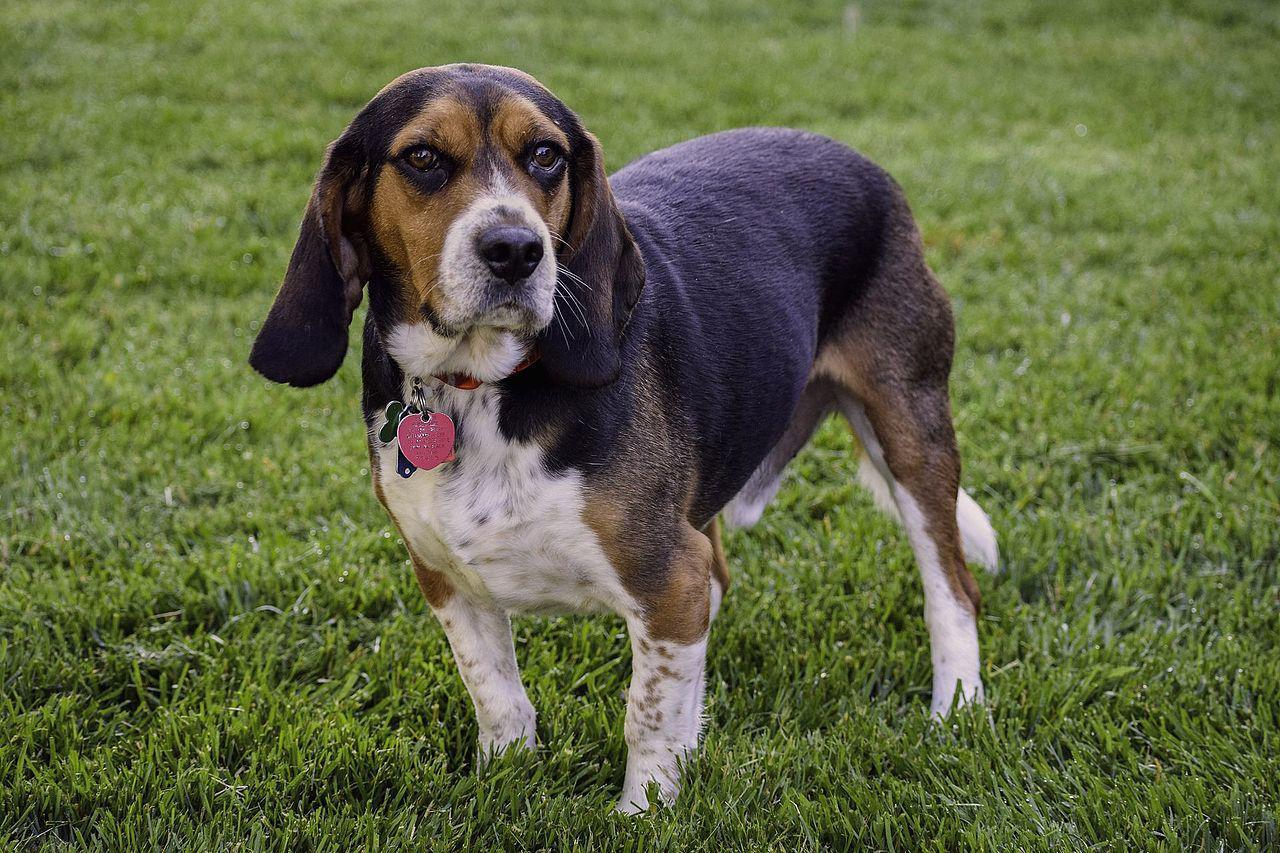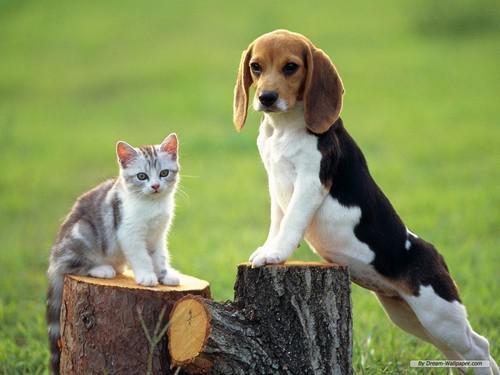The first image is the image on the left, the second image is the image on the right. Analyze the images presented: Is the assertion "There are no more than two animals" valid? Answer yes or no. No. 